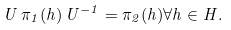Convert formula to latex. <formula><loc_0><loc_0><loc_500><loc_500>U \, \pi _ { 1 } ( h ) \, U ^ { - 1 } = \pi _ { 2 } ( h ) \forall h \in H .</formula> 